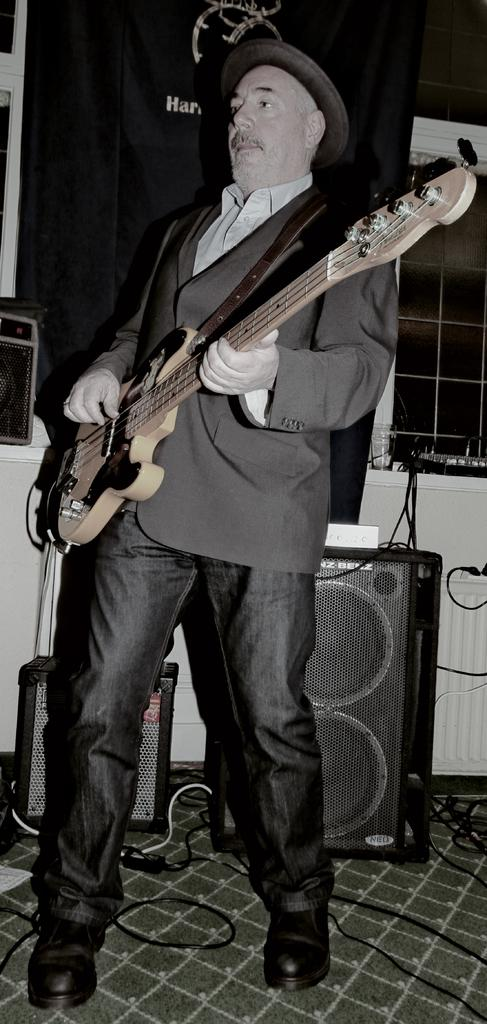What is the main subject of the image? The main subject of the image is a man. What is the man doing in the image? The man is standing and playing the guitar. What type of pig can be seen in the image? There is no pig present in the image; it features a man standing and playing the guitar. 